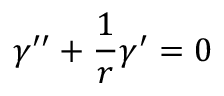Convert formula to latex. <formula><loc_0><loc_0><loc_500><loc_500>\gamma ^ { \prime \prime } + \frac { 1 } { r } \gamma ^ { \prime } = 0</formula> 